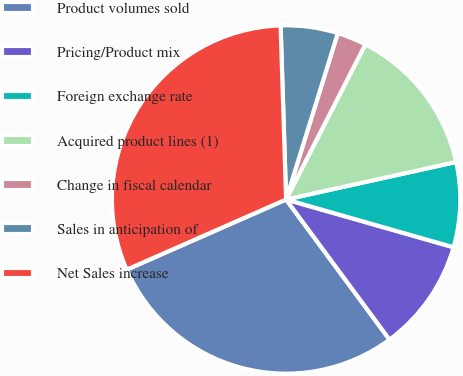Convert chart. <chart><loc_0><loc_0><loc_500><loc_500><pie_chart><fcel>Product volumes sold<fcel>Pricing/Product mix<fcel>Foreign exchange rate<fcel>Acquired product lines (1)<fcel>Change in fiscal calendar<fcel>Sales in anticipation of<fcel>Net Sales increase<nl><fcel>28.52%<fcel>10.46%<fcel>7.88%<fcel>14.03%<fcel>2.72%<fcel>5.3%<fcel>31.1%<nl></chart> 